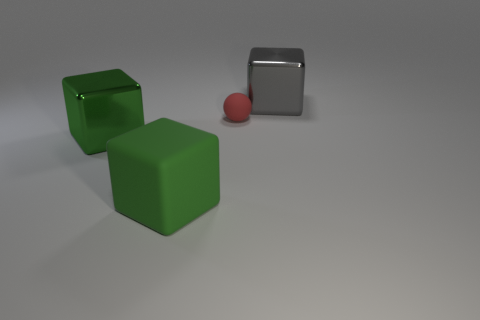Subtract all purple cylinders. How many green cubes are left? 2 Subtract all green shiny cubes. How many cubes are left? 2 Add 2 balls. How many objects exist? 6 Subtract all green blocks. How many blocks are left? 1 Subtract all cubes. How many objects are left? 1 Subtract 1 cubes. How many cubes are left? 2 Add 4 big gray cubes. How many big gray cubes are left? 5 Add 4 small blue blocks. How many small blue blocks exist? 4 Subtract 0 brown cubes. How many objects are left? 4 Subtract all cyan blocks. Subtract all gray cylinders. How many blocks are left? 3 